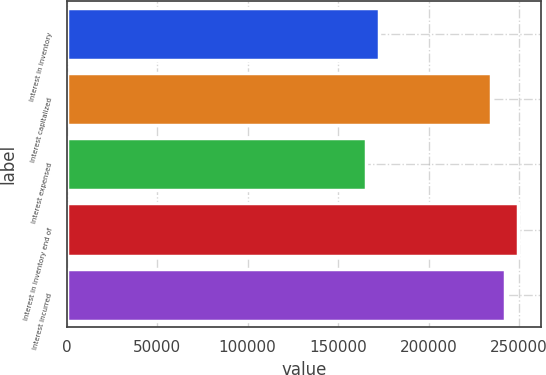Convert chart to OTSL. <chart><loc_0><loc_0><loc_500><loc_500><bar_chart><fcel>Interest in inventory<fcel>Interest capitalized<fcel>Interest expensed<fcel>Interest in inventory end of<fcel>Interest incurred<nl><fcel>172756<fcel>234700<fcel>165355<fcel>249502<fcel>242101<nl></chart> 